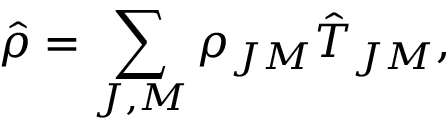<formula> <loc_0><loc_0><loc_500><loc_500>\hat { \rho } = \sum _ { J , M } \rho _ { J M } { \hat { T } } _ { J M } ,</formula> 